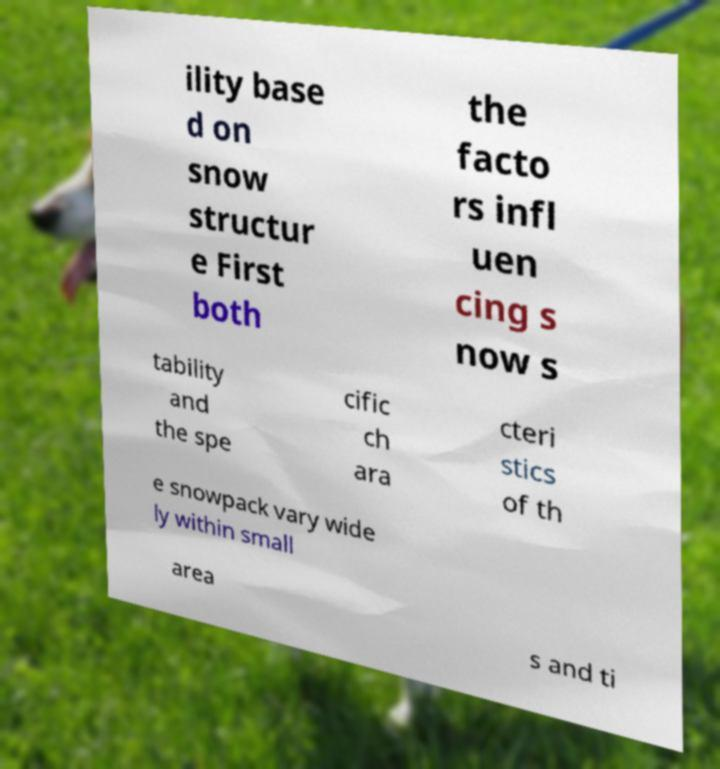Can you read and provide the text displayed in the image?This photo seems to have some interesting text. Can you extract and type it out for me? ility base d on snow structur e First both the facto rs infl uen cing s now s tability and the spe cific ch ara cteri stics of th e snowpack vary wide ly within small area s and ti 